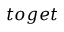Convert formula to latex. <formula><loc_0><loc_0><loc_500><loc_500>t o g e t</formula> 